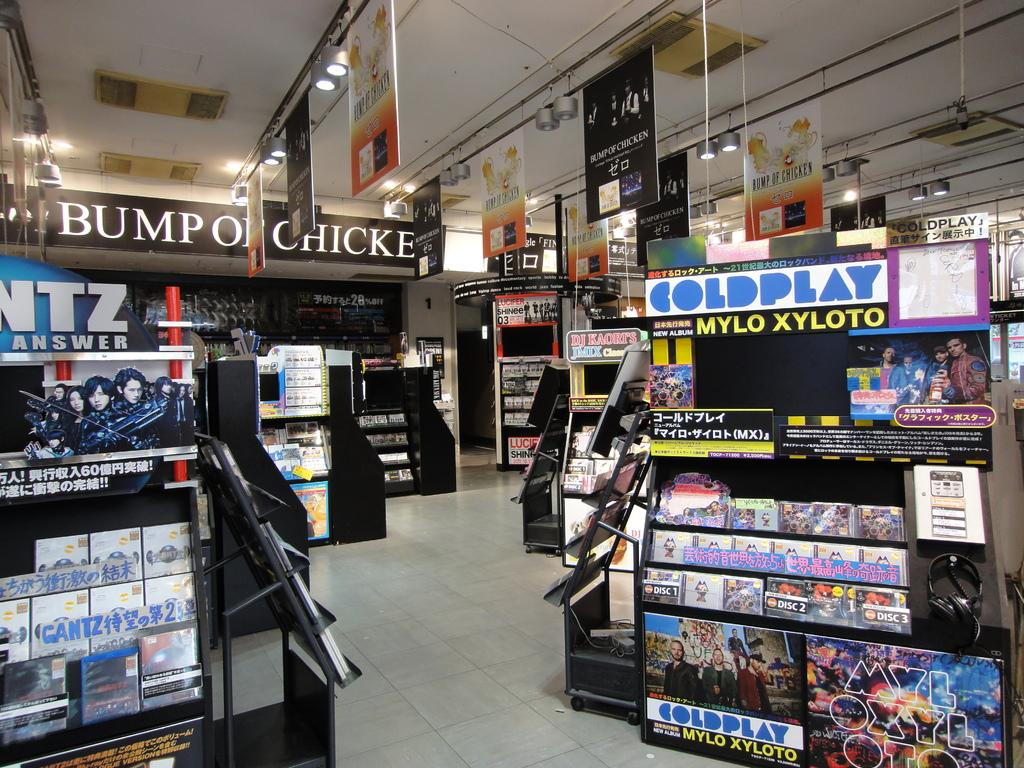Provide a one-sentence caption for the provided image. The band Coldplay is being adverstised inside this store. 